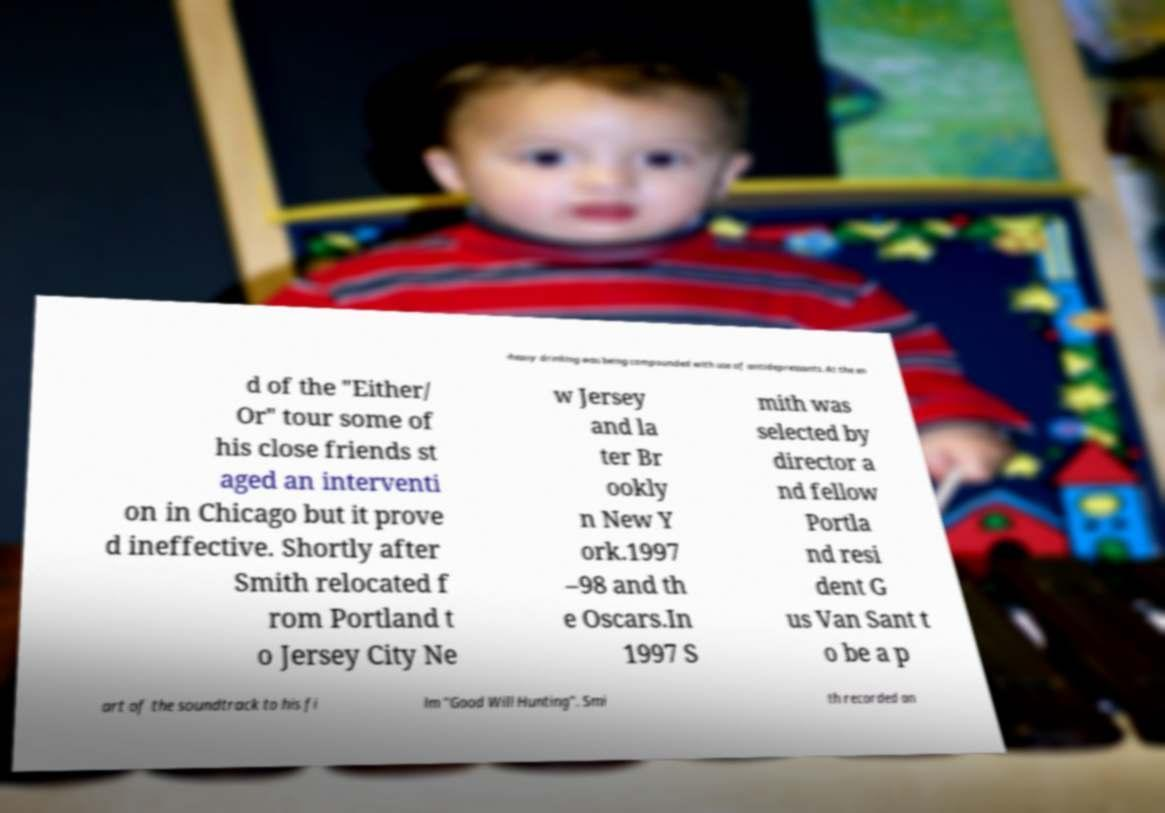Could you extract and type out the text from this image? -heavy drinking was being compounded with use of antidepressants. At the en d of the "Either/ Or" tour some of his close friends st aged an interventi on in Chicago but it prove d ineffective. Shortly after Smith relocated f rom Portland t o Jersey City Ne w Jersey and la ter Br ookly n New Y ork.1997 –98 and th e Oscars.In 1997 S mith was selected by director a nd fellow Portla nd resi dent G us Van Sant t o be a p art of the soundtrack to his fi lm "Good Will Hunting". Smi th recorded an 